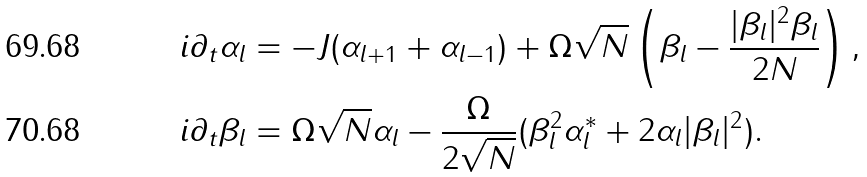<formula> <loc_0><loc_0><loc_500><loc_500>i \partial _ { t } \alpha _ { l } & = - J ( \alpha _ { l + 1 } + \alpha _ { l - 1 } ) + \Omega \sqrt { N } \left ( \beta _ { l } - \frac { | \beta _ { l } | ^ { 2 } \beta _ { l } } { 2 N } \right ) , \\ i \partial _ { t } \beta _ { l } & = \Omega \sqrt { N } \alpha _ { l } - \frac { \Omega } { 2 \sqrt { N } } ( \beta ^ { 2 } _ { l } \alpha ^ { * } _ { l } + 2 \alpha _ { l } | \beta _ { l } | ^ { 2 } ) .</formula> 